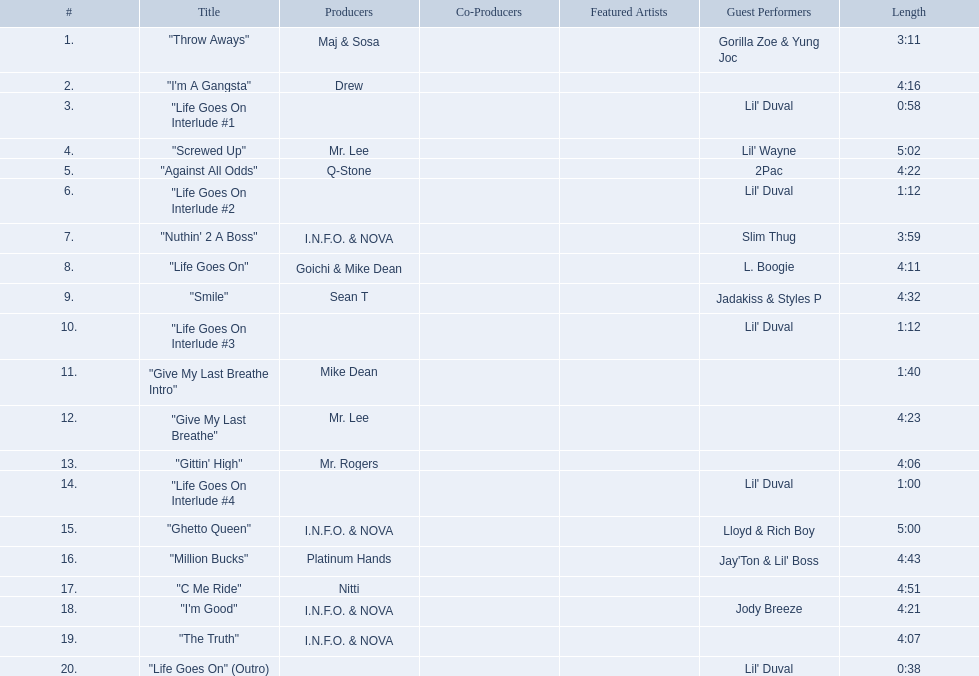What tracks appear on the album life goes on (trae album)? "Throw Aways", "I'm A Gangsta", "Life Goes On Interlude #1, "Screwed Up", "Against All Odds", "Life Goes On Interlude #2, "Nuthin' 2 A Boss", "Life Goes On", "Smile", "Life Goes On Interlude #3, "Give My Last Breathe Intro", "Give My Last Breathe", "Gittin' High", "Life Goes On Interlude #4, "Ghetto Queen", "Million Bucks", "C Me Ride", "I'm Good", "The Truth", "Life Goes On" (Outro). Could you parse the entire table? {'header': ['#', 'Title', 'Producers', 'Co-Producers', 'Featured Artists', 'Guest Performers', 'Length'], 'rows': [['1.', '"Throw Aways"', 'Maj & Sosa', '', '', 'Gorilla Zoe & Yung Joc', '3:11'], ['2.', '"I\'m A Gangsta"', 'Drew', '', '', '', '4:16'], ['3.', '"Life Goes On Interlude #1', '', '', '', "Lil' Duval", '0:58'], ['4.', '"Screwed Up"', 'Mr. Lee', '', '', "Lil' Wayne", '5:02'], ['5.', '"Against All Odds"', 'Q-Stone', '', '', '2Pac', '4:22'], ['6.', '"Life Goes On Interlude #2', '', '', '', "Lil' Duval", '1:12'], ['7.', '"Nuthin\' 2 A Boss"', 'I.N.F.O. & NOVA', '', '', 'Slim Thug', '3:59'], ['8.', '"Life Goes On"', 'Goichi & Mike Dean', '', '', 'L. Boogie', '4:11'], ['9.', '"Smile"', 'Sean T', '', '', 'Jadakiss & Styles P', '4:32'], ['10.', '"Life Goes On Interlude #3', '', '', '', "Lil' Duval", '1:12'], ['11.', '"Give My Last Breathe Intro"', 'Mike Dean', '', '', '', '1:40'], ['12.', '"Give My Last Breathe"', 'Mr. Lee', '', '', '', '4:23'], ['13.', '"Gittin\' High"', 'Mr. Rogers', '', '', '', '4:06'], ['14.', '"Life Goes On Interlude #4', '', '', '', "Lil' Duval", '1:00'], ['15.', '"Ghetto Queen"', 'I.N.F.O. & NOVA', '', '', 'Lloyd & Rich Boy', '5:00'], ['16.', '"Million Bucks"', 'Platinum Hands', '', '', "Jay'Ton & Lil' Boss", '4:43'], ['17.', '"C Me Ride"', 'Nitti', '', '', '', '4:51'], ['18.', '"I\'m Good"', 'I.N.F.O. & NOVA', '', '', 'Jody Breeze', '4:21'], ['19.', '"The Truth"', 'I.N.F.O. & NOVA', '', '', '', '4:07'], ['20.', '"Life Goes On" (Outro)', '', '', '', "Lil' Duval", '0:38']]} Which of these songs are at least 5 minutes long? "Screwed Up", "Ghetto Queen". Of these two songs over 5 minutes long, which is longer? "Screwed Up". How long is this track? 5:02. 